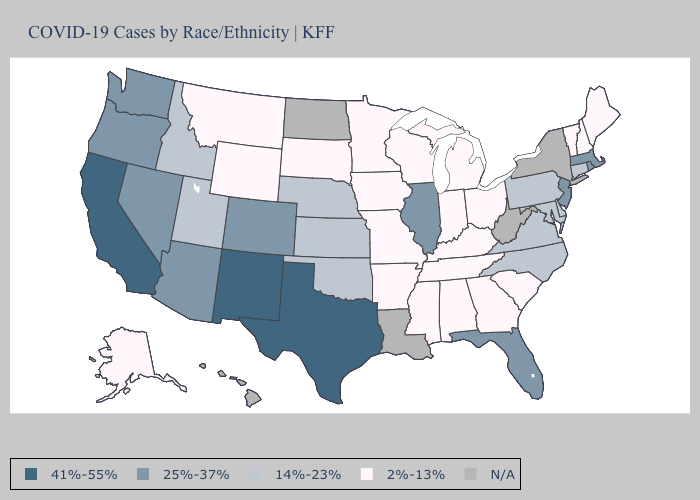What is the value of Louisiana?
Give a very brief answer. N/A. Among the states that border Oklahoma , does New Mexico have the highest value?
Be succinct. Yes. Which states have the lowest value in the USA?
Concise answer only. Alabama, Alaska, Arkansas, Georgia, Indiana, Iowa, Kentucky, Maine, Michigan, Minnesota, Mississippi, Missouri, Montana, New Hampshire, Ohio, South Carolina, South Dakota, Tennessee, Vermont, Wisconsin, Wyoming. What is the highest value in the USA?
Write a very short answer. 41%-55%. Name the states that have a value in the range 2%-13%?
Short answer required. Alabama, Alaska, Arkansas, Georgia, Indiana, Iowa, Kentucky, Maine, Michigan, Minnesota, Mississippi, Missouri, Montana, New Hampshire, Ohio, South Carolina, South Dakota, Tennessee, Vermont, Wisconsin, Wyoming. Among the states that border New Hampshire , does Maine have the lowest value?
Answer briefly. Yes. What is the value of Illinois?
Be succinct. 25%-37%. What is the highest value in states that border Indiana?
Short answer required. 25%-37%. Name the states that have a value in the range 25%-37%?
Write a very short answer. Arizona, Colorado, Florida, Illinois, Massachusetts, Nevada, New Jersey, Oregon, Rhode Island, Washington. What is the value of Michigan?
Concise answer only. 2%-13%. Name the states that have a value in the range N/A?
Answer briefly. Hawaii, Louisiana, New York, North Dakota, West Virginia. What is the value of Rhode Island?
Concise answer only. 25%-37%. Name the states that have a value in the range 41%-55%?
Answer briefly. California, New Mexico, Texas. Among the states that border Texas , which have the lowest value?
Write a very short answer. Arkansas. 